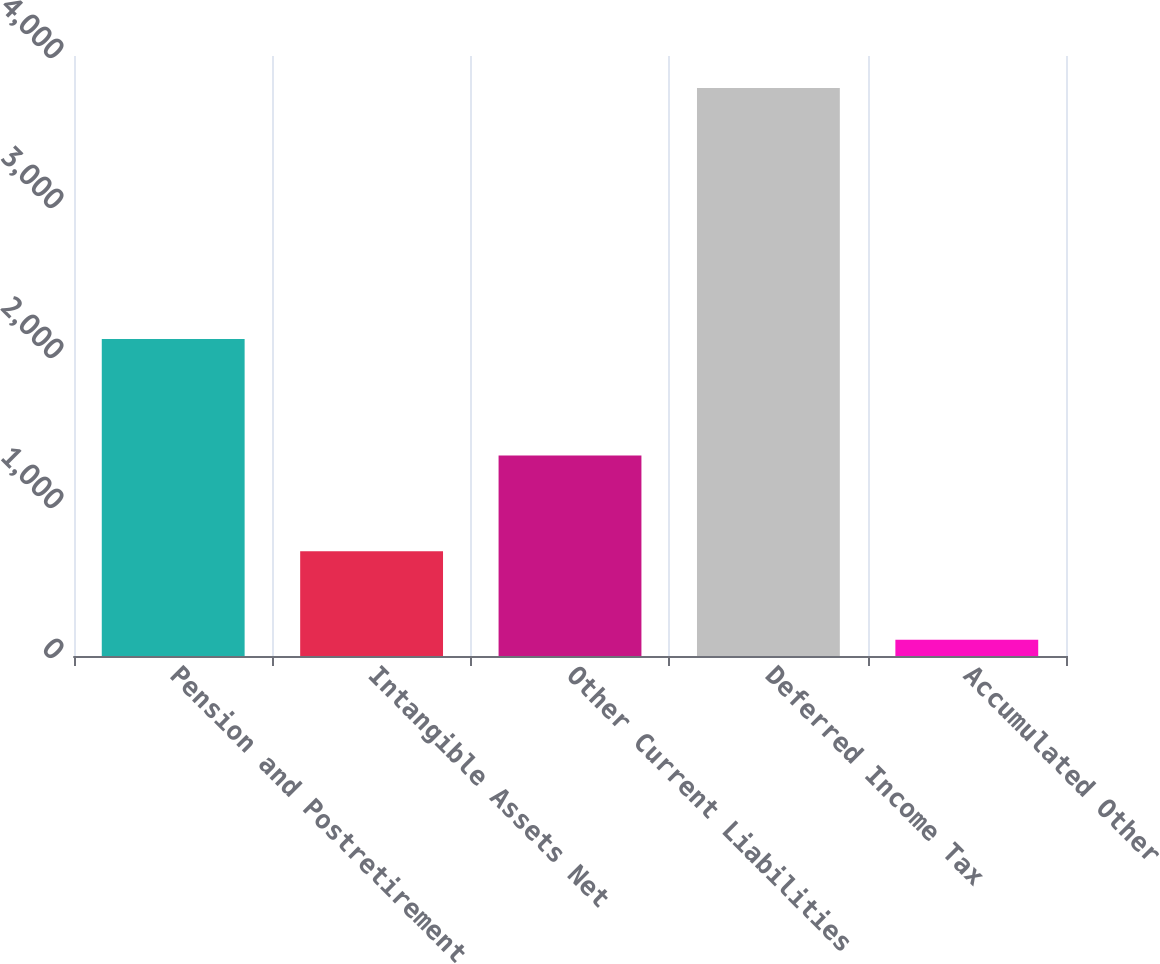Convert chart. <chart><loc_0><loc_0><loc_500><loc_500><bar_chart><fcel>Pension and Postretirement<fcel>Intangible Assets Net<fcel>Other Current Liabilities<fcel>Deferred Income Tax<fcel>Accumulated Other<nl><fcel>2114<fcel>699<fcel>1336<fcel>3787<fcel>108<nl></chart> 